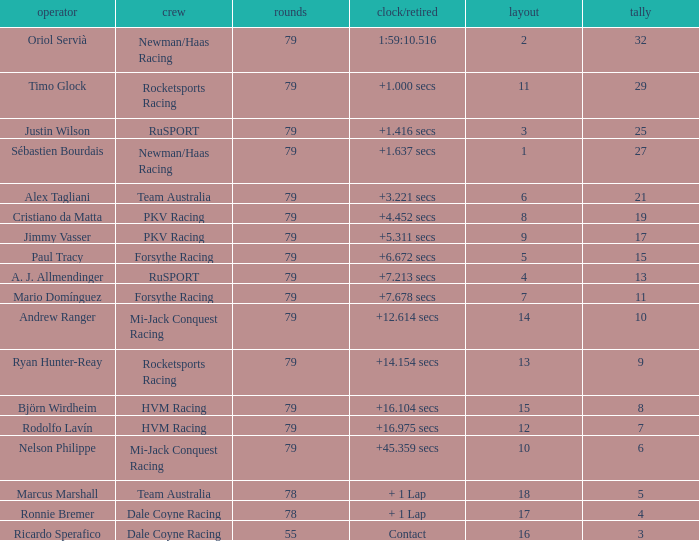Parse the full table. {'header': ['operator', 'crew', 'rounds', 'clock/retired', 'layout', 'tally'], 'rows': [['Oriol Servià', 'Newman/Haas Racing', '79', '1:59:10.516', '2', '32'], ['Timo Glock', 'Rocketsports Racing', '79', '+1.000 secs', '11', '29'], ['Justin Wilson', 'RuSPORT', '79', '+1.416 secs', '3', '25'], ['Sébastien Bourdais', 'Newman/Haas Racing', '79', '+1.637 secs', '1', '27'], ['Alex Tagliani', 'Team Australia', '79', '+3.221 secs', '6', '21'], ['Cristiano da Matta', 'PKV Racing', '79', '+4.452 secs', '8', '19'], ['Jimmy Vasser', 'PKV Racing', '79', '+5.311 secs', '9', '17'], ['Paul Tracy', 'Forsythe Racing', '79', '+6.672 secs', '5', '15'], ['A. J. Allmendinger', 'RuSPORT', '79', '+7.213 secs', '4', '13'], ['Mario Domínguez', 'Forsythe Racing', '79', '+7.678 secs', '7', '11'], ['Andrew Ranger', 'Mi-Jack Conquest Racing', '79', '+12.614 secs', '14', '10'], ['Ryan Hunter-Reay', 'Rocketsports Racing', '79', '+14.154 secs', '13', '9'], ['Björn Wirdheim', 'HVM Racing', '79', '+16.104 secs', '15', '8'], ['Rodolfo Lavín', 'HVM Racing', '79', '+16.975 secs', '12', '7'], ['Nelson Philippe', 'Mi-Jack Conquest Racing', '79', '+45.359 secs', '10', '6'], ['Marcus Marshall', 'Team Australia', '78', '+ 1 Lap', '18', '5'], ['Ronnie Bremer', 'Dale Coyne Racing', '78', '+ 1 Lap', '17', '4'], ['Ricardo Sperafico', 'Dale Coyne Racing', '55', 'Contact', '16', '3']]} What grid has 78 laps, and Ronnie Bremer as driver? 17.0. 